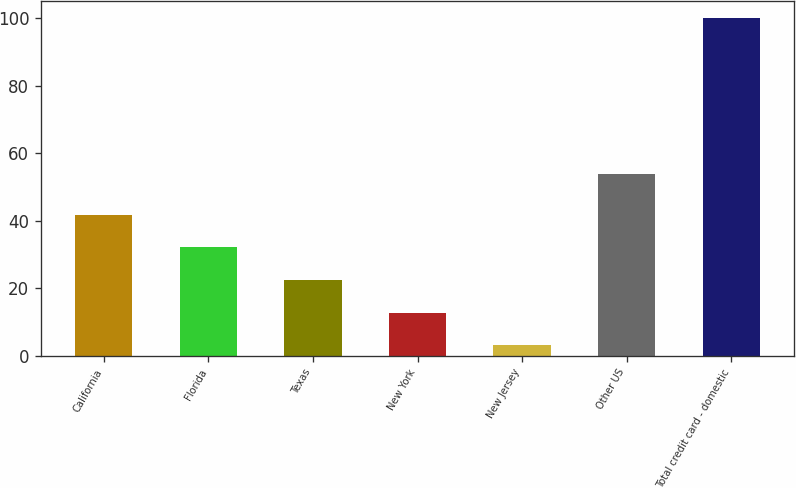Convert chart to OTSL. <chart><loc_0><loc_0><loc_500><loc_500><bar_chart><fcel>California<fcel>Florida<fcel>Texas<fcel>New York<fcel>New Jersey<fcel>Other US<fcel>Total credit card - domestic<nl><fcel>41.86<fcel>32.17<fcel>22.48<fcel>12.79<fcel>3.1<fcel>54<fcel>100<nl></chart> 